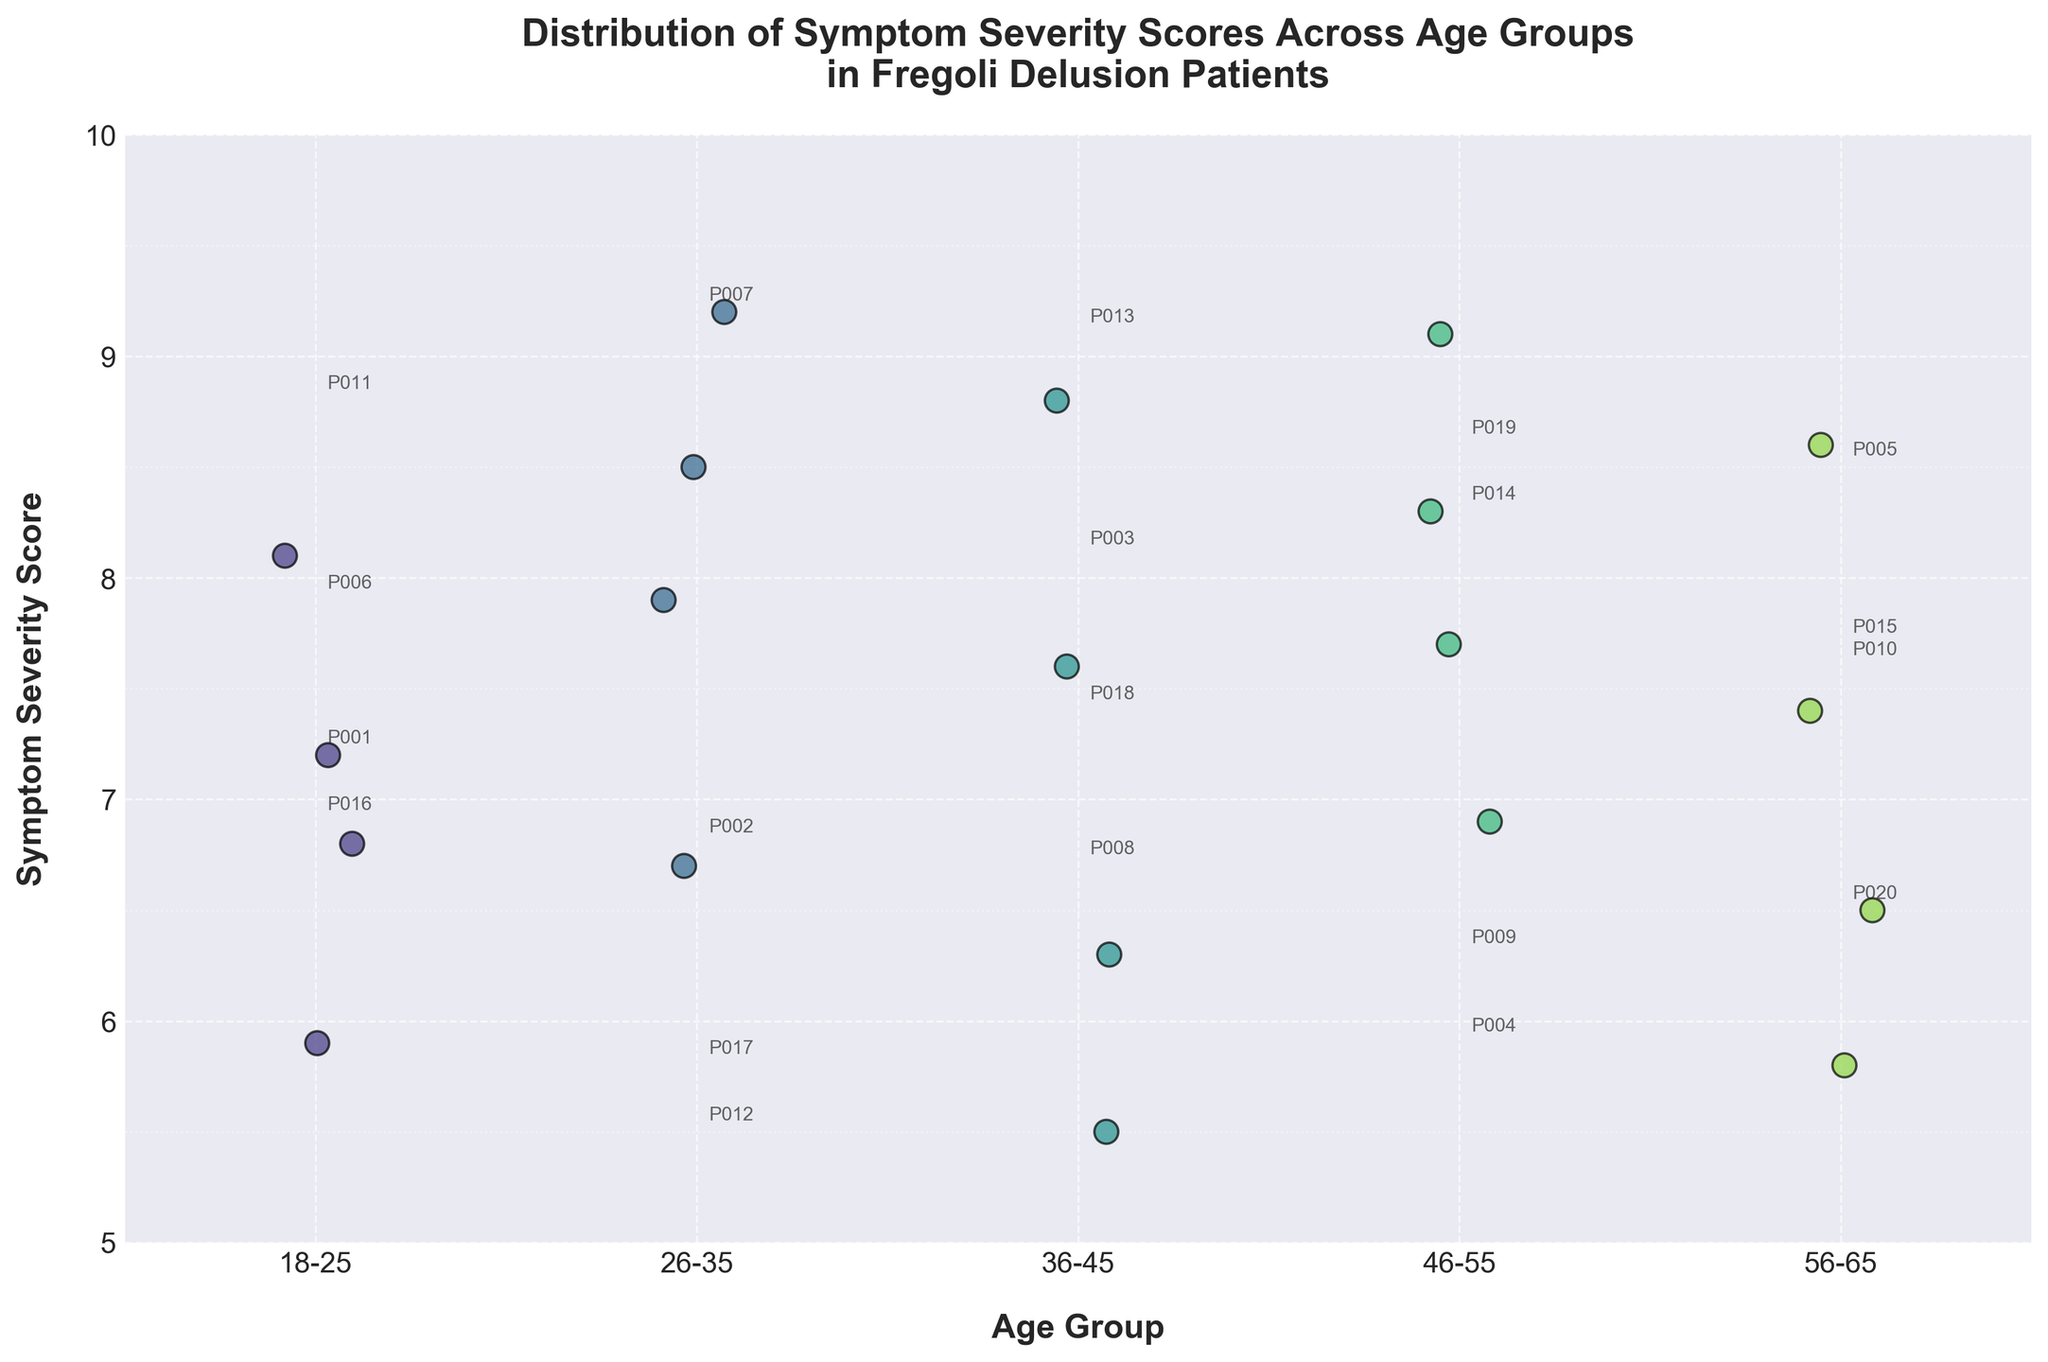What is the title of the figure? The title is shown at the top of the figure in bold font. It provides an overview of what the figure is about.
Answer: Distribution of Symptom Severity Scores Across Age Groups in Fregoli Delusion Patients What are the labels on the x-axis and y-axis? The x-axis and y-axis labels are shown below and to the left of the axes respectively in bold font. They describe what each axis represents.
Answer: Age Group (x-axis) and Symptom Severity Score (y-axis) Which age group has the highest variability in symptom severity scores? By visually inspecting the spread of the data points (vertical dots) within each age group, the group with the widest spread has the highest variability.
Answer: 26-35 How many patients are in the 46-55 age group? By counting the individual data points (dots) within the 46-55 age group category on the x-axis.
Answer: 4 Which age group has the lowest symptom severity score and what is it? By locating the lowest data point (dot) within each group and finding the one with the lowest y-value.
Answer: 36-45 with a score of 5.5 What is the mean symptom severity score for patients aged 18-25? First, find all the data points in the 18-25 age group, sum their scores, and divide by the number of data points. Scores are 7.2, 6.8, 8.1, 5.9; mean = (7.2 + 6.8 + 8.1 + 5.9) / 4.
Answer: 7.0 Do any age groups have the same number of patients? By counting and comparing the number of data points within each age group, identify any groups with an equal count. 18-25 and 56-65 both have 4; 26-35 and 36-45 also both have 4.
Answer: Yes Which age group has the highest average symptom severity score? Calculate the average score for each age group and compare them. Average scores for each group: 18-25: 7.0, 26-35: 8.075, 36-45: 7.05, 46-55: 8.0, 56-65: 7.075.
Answer: 26-35 Is there any overlap in symptom severity scores between the youngest and oldest age groups? Compare the range of scores within the 18-25 group and the 56-65 group to see if they share any common y-values. 18-25: 5.9-8.1, 56-65: 5.8-8.6.
Answer: Yes 